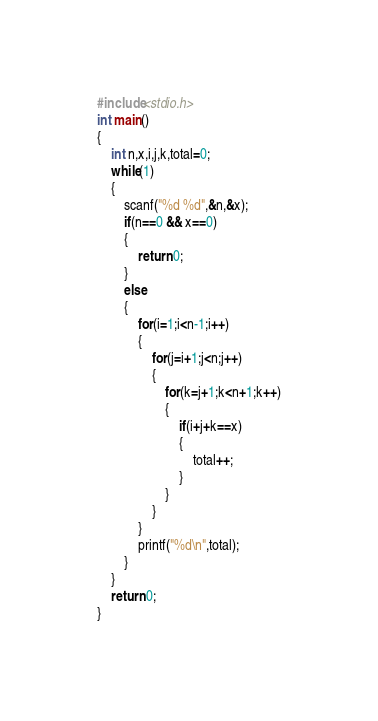Convert code to text. <code><loc_0><loc_0><loc_500><loc_500><_C_>#include<stdio.h>
int main()
{
    int n,x,i,j,k,total=0;
    while(1)
    {
        scanf("%d %d",&n,&x);
        if(n==0 && x==0)
        {
            return 0;
        }
        else
        {
            for(i=1;i<n-1;i++)
            {
                for(j=i+1;j<n;j++)
                {
                    for(k=j+1;k<n+1;k++)
                    {
                        if(i+j+k==x)
                        {
                            total++;
                        }
                    }
                }
            }
            printf("%d\n",total);
        }
    }
    return 0;
}

</code> 